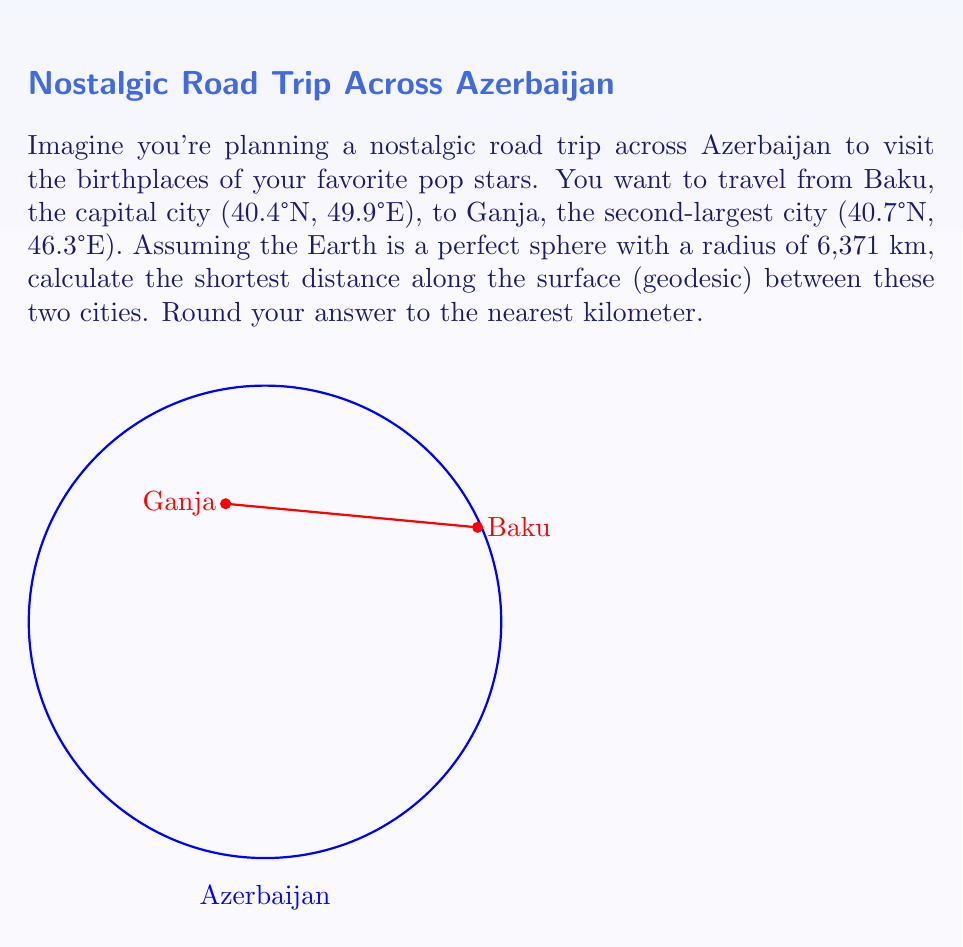Help me with this question. To solve this problem, we'll use the Haversine formula, which calculates the great-circle distance between two points on a sphere given their longitudes and latitudes. Let's break it down step-by-step:

1) Convert the coordinates to radians:
   Baku: $\phi_1 = 40.4° \times \frac{\pi}{180} = 0.7051$ rad, $\lambda_1 = 49.9° \times \frac{\pi}{180} = 0.8710$ rad
   Ganja: $\phi_2 = 40.7° \times \frac{\pi}{180} = 0.7103$ rad, $\lambda_2 = 46.3° \times \frac{\pi}{180} = 0.8081$ rad

2) Calculate the difference in longitude:
   $\Delta \lambda = \lambda_2 - \lambda_1 = 0.8081 - 0.8710 = -0.0629$ rad

3) Apply the Haversine formula:
   $$a = \sin^2(\frac{\Delta\phi}{2}) + \cos(\phi_1) \cos(\phi_2) \sin^2(\frac{\Delta\lambda}{2})$$
   $$c = 2 \times \arctan2(\sqrt{a}, \sqrt{1-a})$$
   
   Where $\Delta\phi = \phi_2 - \phi_1 = 0.7103 - 0.7051 = 0.0052$ rad

4) Calculate $a$:
   $$a = \sin^2(0.0026) + \cos(0.7051) \cos(0.7103) \sin^2(-0.03145)$$
   $$a = 0.000007 + 0.7564 \times 0.7541 \times 0.000987 = 0.000562$$

5) Calculate $c$:
   $$c = 2 \times \arctan2(\sqrt{0.000562}, \sqrt{1-0.000562}) = 0.0474$$

6) The distance $d$ is given by $d = R \times c$ where $R$ is the Earth's radius:
   $$d = 6371 \times 0.0474 = 302.0854 \text{ km}$$

7) Rounding to the nearest kilometer:
   $$d \approx 302 \text{ km}$$
Answer: 302 km 